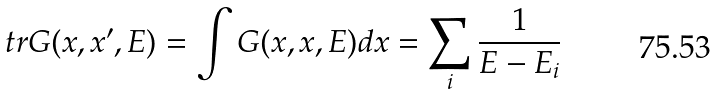Convert formula to latex. <formula><loc_0><loc_0><loc_500><loc_500>t r G ( x , x ^ { \prime } , E ) = \int G ( x , x , E ) d x = \sum _ { i } \frac { 1 } { E - E _ { i } }</formula> 